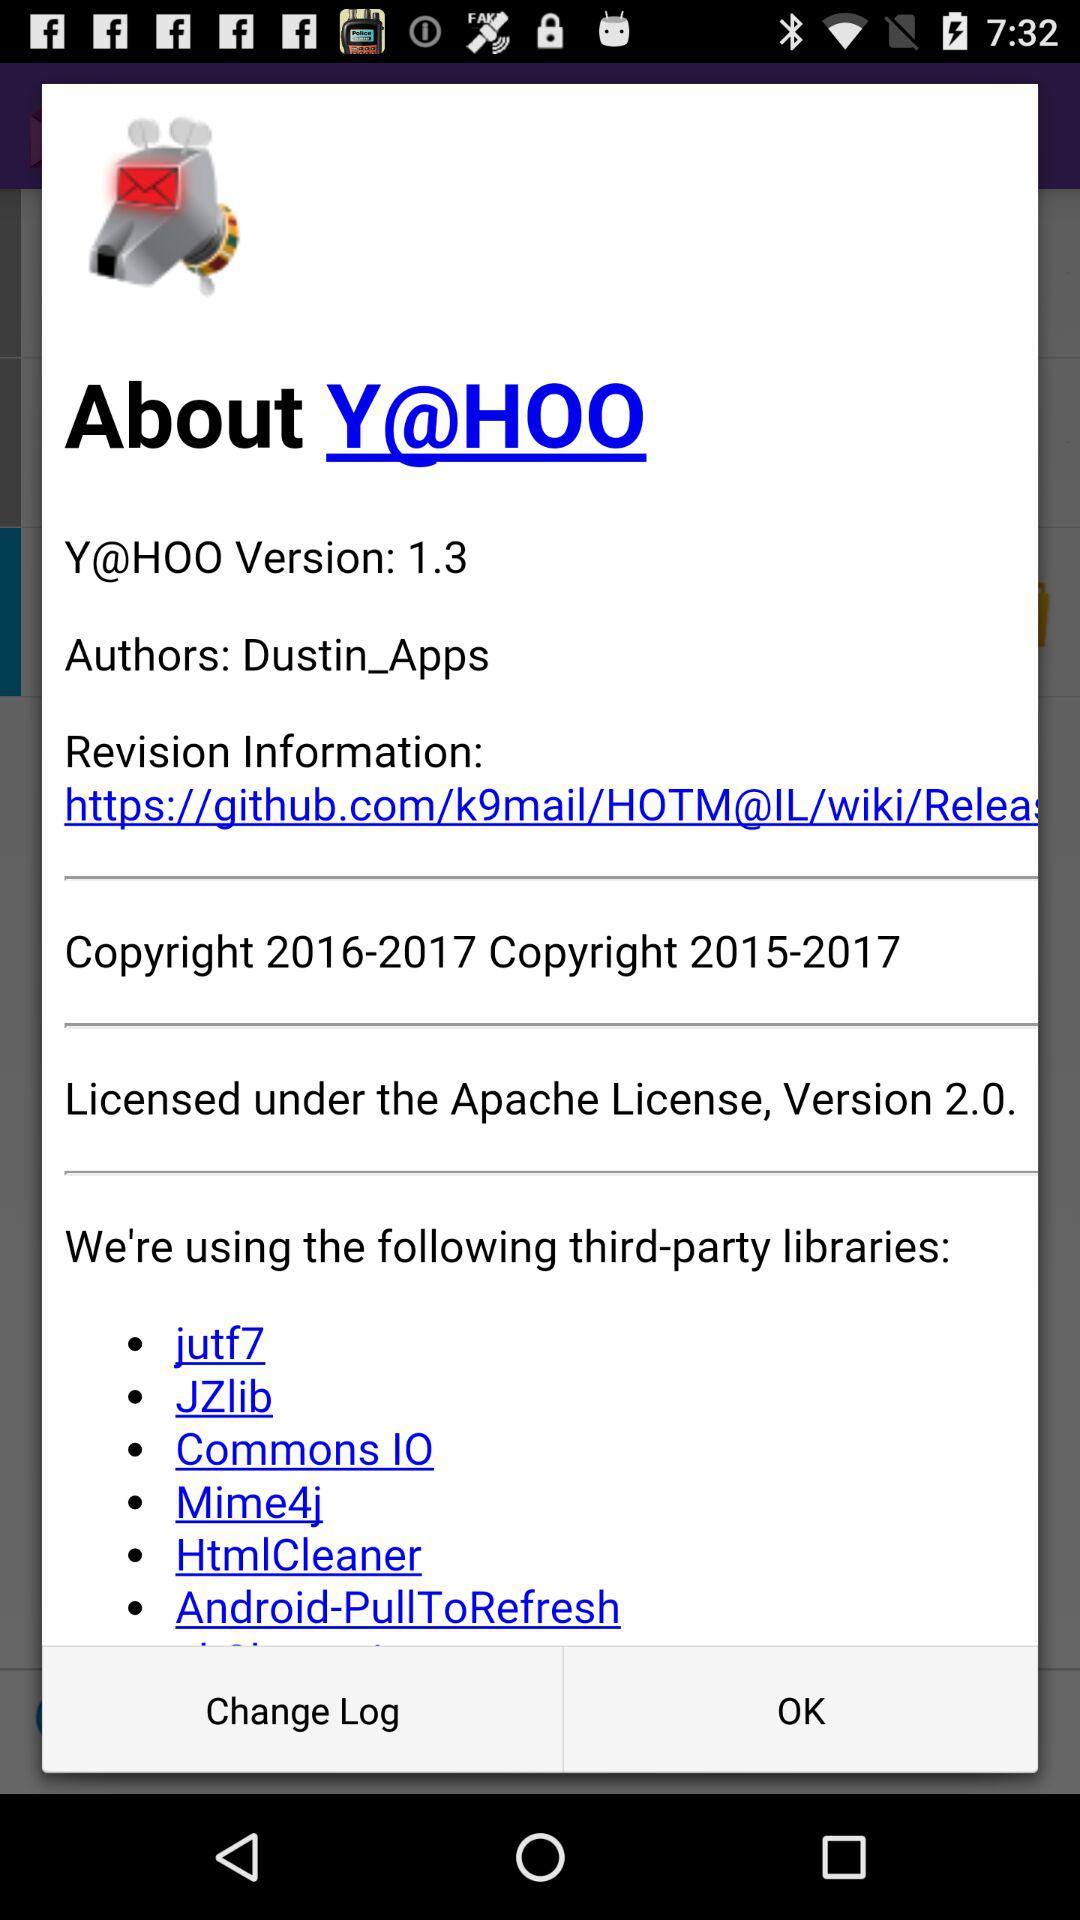How many third-party libraries are used? The image shows a list of six third-party libraries used within the software: jutf7, JZlib, Commons IO, Mime4j, HtmlCleaner, and Android-PullToRefresh. 